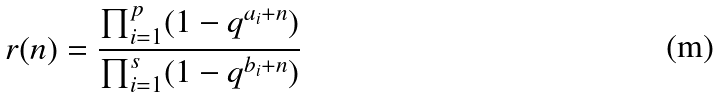<formula> <loc_0><loc_0><loc_500><loc_500>r ( n ) = \frac { \prod _ { i = 1 } ^ { p } ( 1 - q ^ { a _ { i } + n } ) } { \prod _ { i = 1 } ^ { s } ( 1 - q ^ { b _ { i } + n } ) }</formula> 